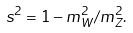Convert formula to latex. <formula><loc_0><loc_0><loc_500><loc_500>s ^ { 2 } = 1 - m _ { W } ^ { 2 } / m _ { Z } ^ { 2 } .</formula> 